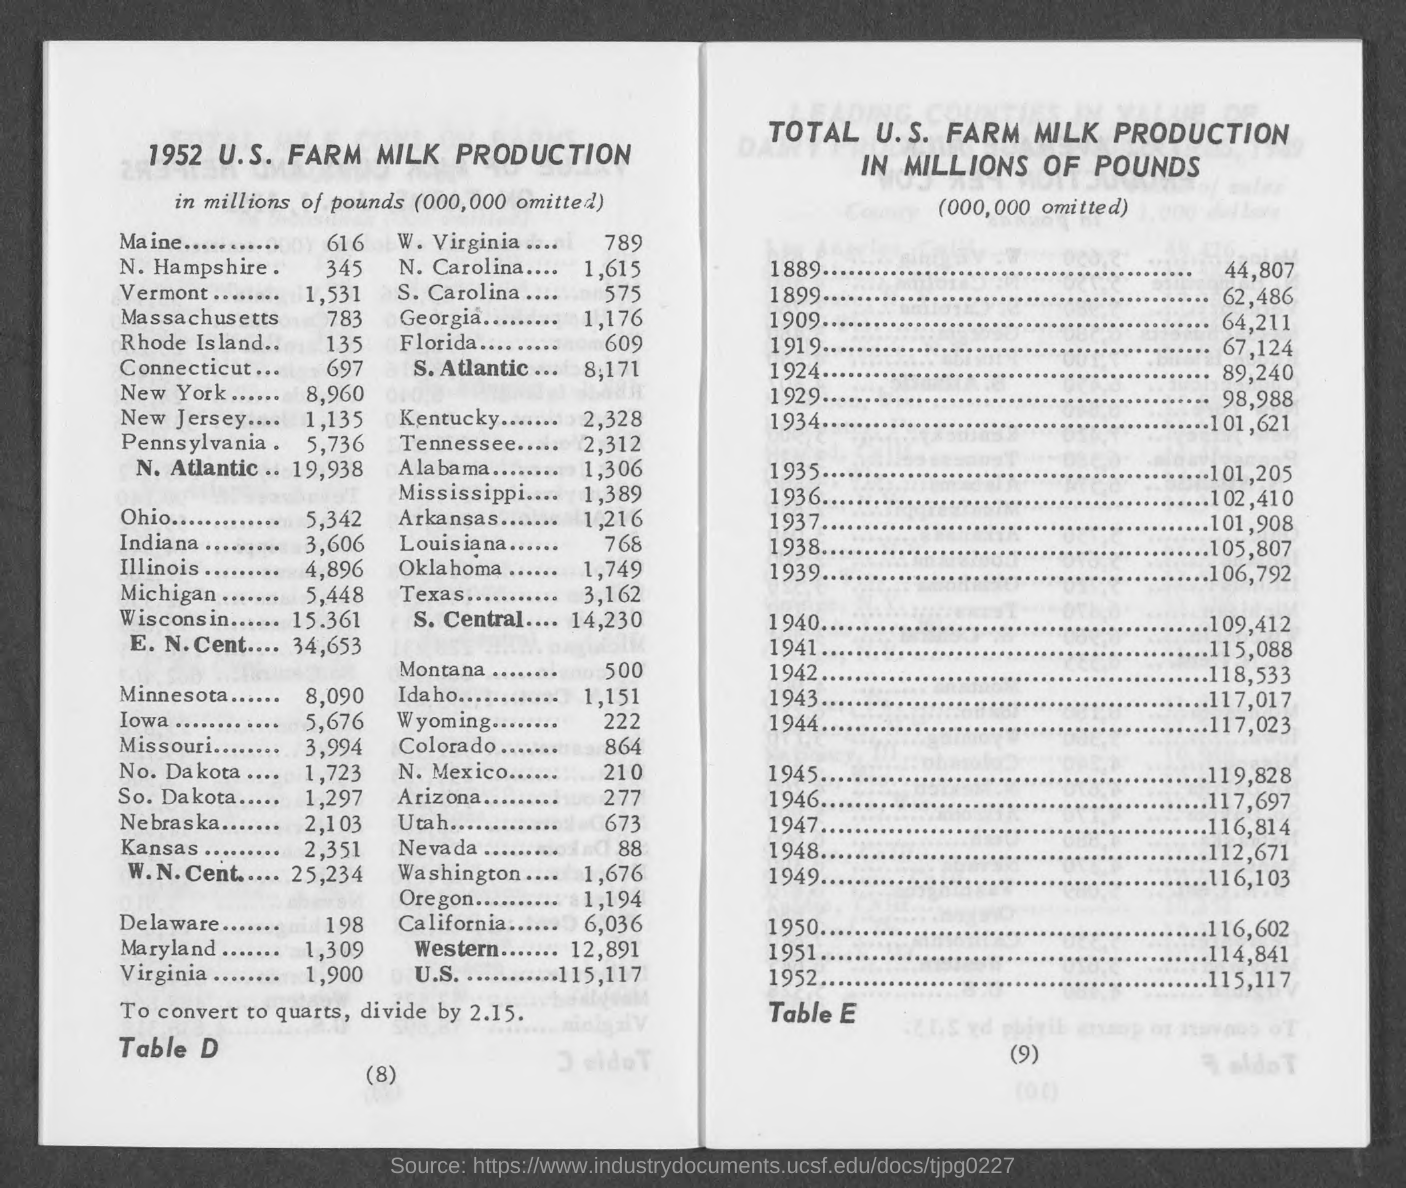What is the 1952  u.s. farm milk production in millions of pounds in maine?
Provide a short and direct response. 616. What is the 1952  u.s. farm milk production in millions of pounds in new hampshire ?
Provide a short and direct response. 345. What is the 1952  u.s. farm milk production in millions of pounds in vermont ?
Provide a short and direct response. 1,531. What is the 1952  u.s. farm milk production in millions of pounds in massachusetts ?
Ensure brevity in your answer.  783. What is the 1952  u.s. farm milk production in millions of pounds in rhode island ?
Your answer should be very brief. 135. What is the 1952  u.s. farm milk production in millions of pounds in connecticut ?
Your response must be concise. 697. What is the 1952  u.s. farm milk production in millions of pounds in new york?
Give a very brief answer. 8,960. What is the 1952  u.s. farm milk production in millions of pounds in new jersey ?
Keep it short and to the point. 1,135. What is the 1952  u.s. farm milk production in millions of pounds in ohio ?
Your response must be concise. 5,342. What is the 1952  u.s. farm milk production in millions of pounds in indiana ?
Keep it short and to the point. 3,606. 